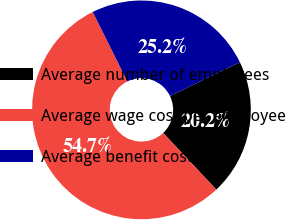Convert chart. <chart><loc_0><loc_0><loc_500><loc_500><pie_chart><fcel>Average number of employees<fcel>Average wage cost per employee<fcel>Average benefit cost per<nl><fcel>20.17%<fcel>54.66%<fcel>25.17%<nl></chart> 